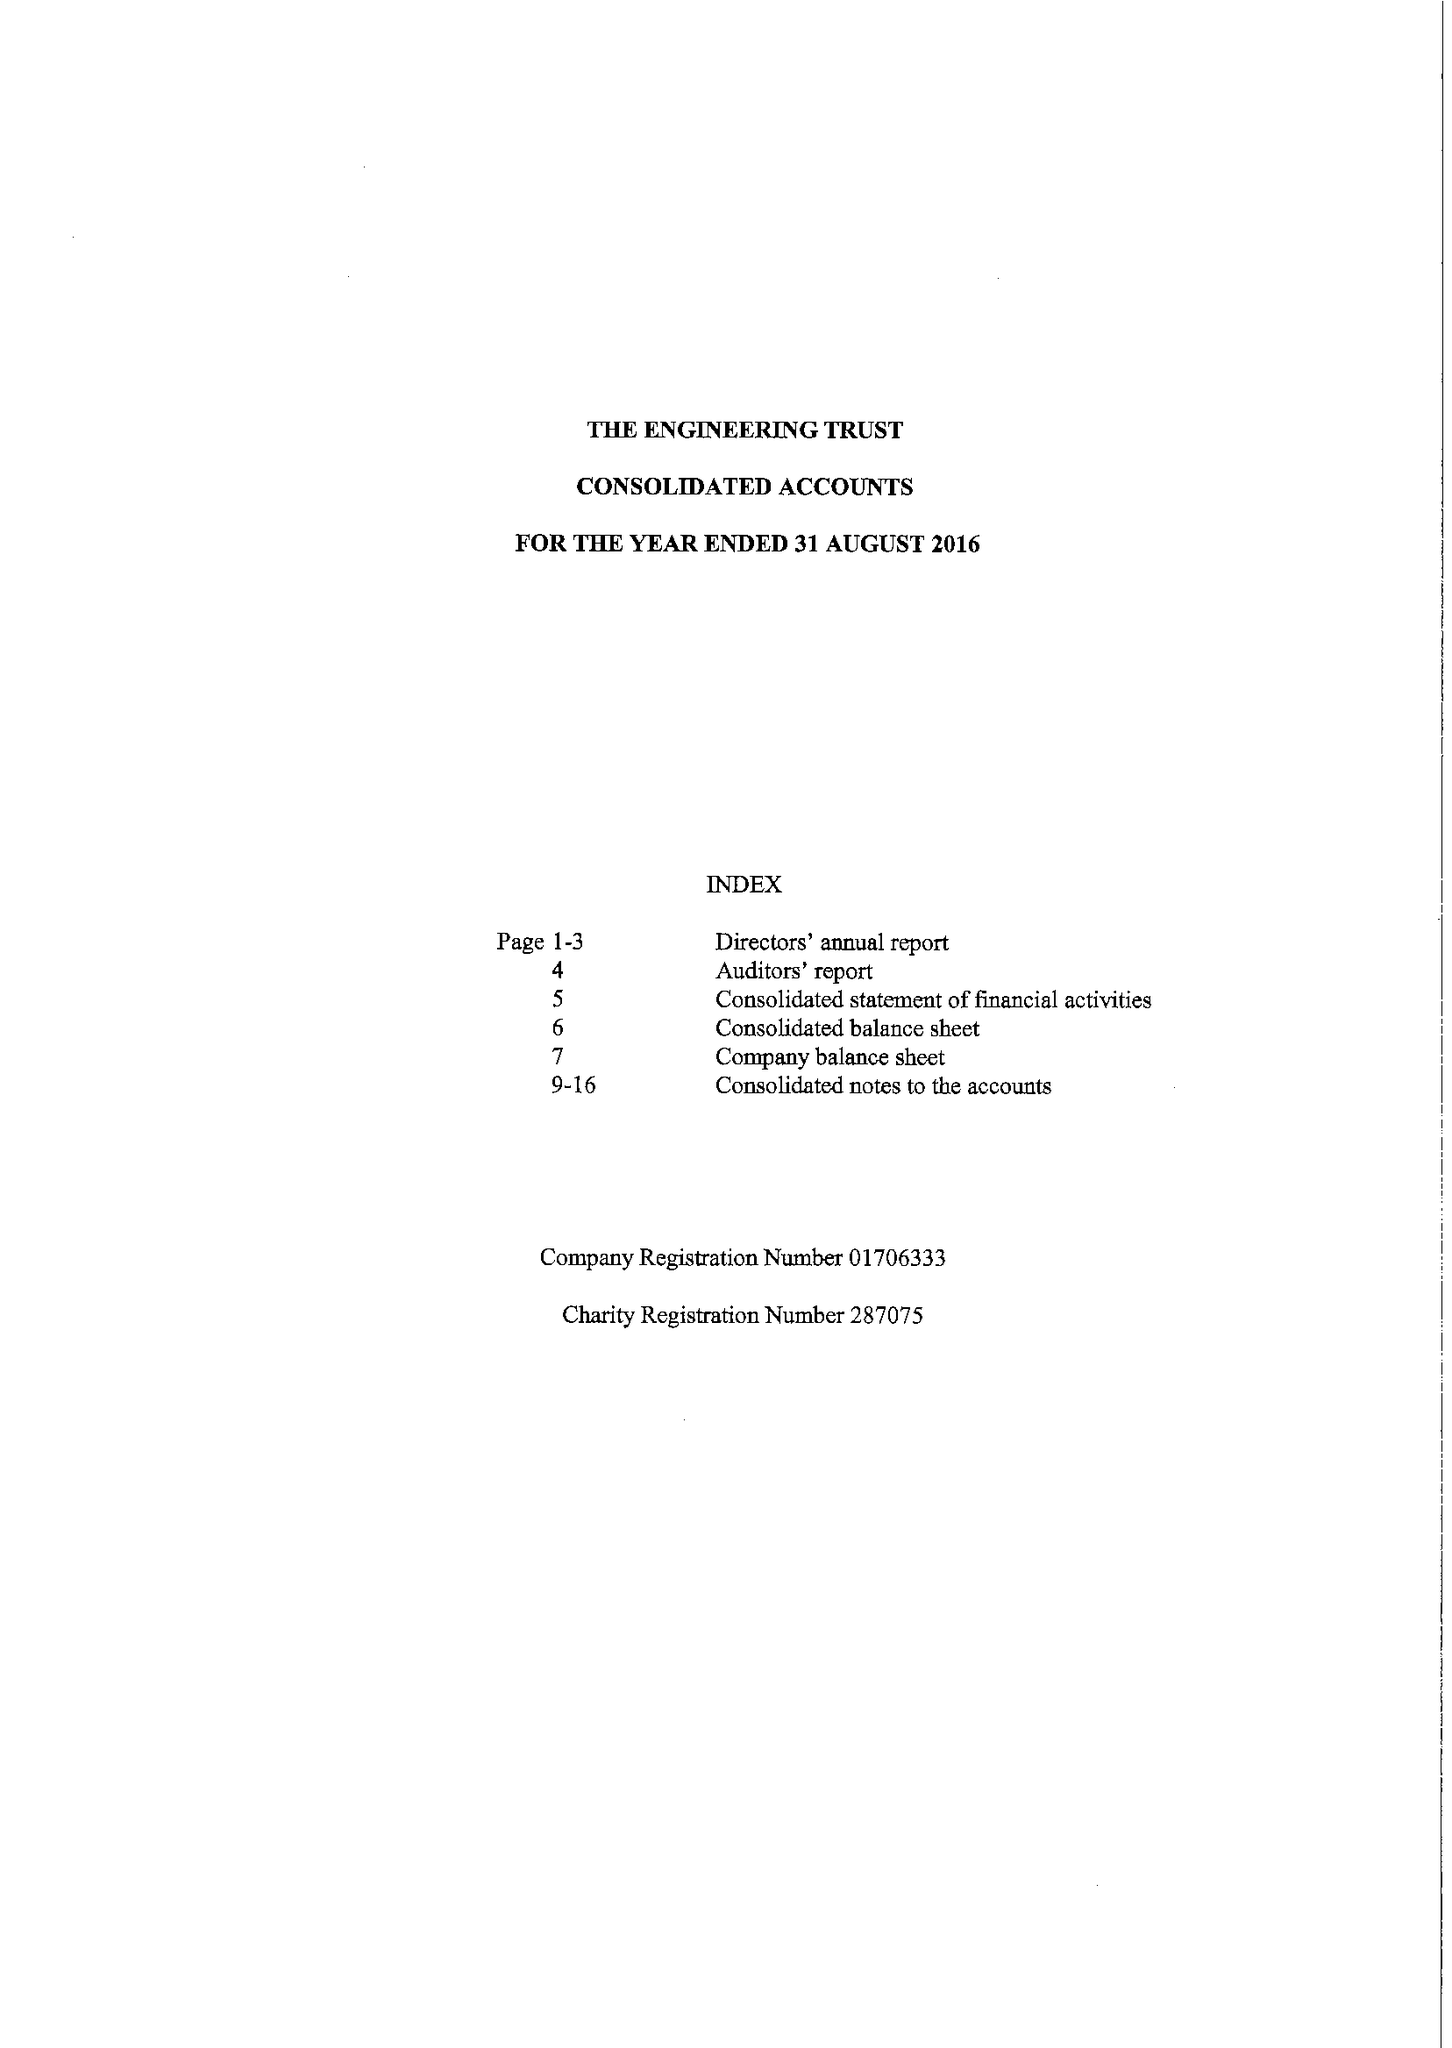What is the value for the address__street_line?
Answer the question using a single word or phrase. None 